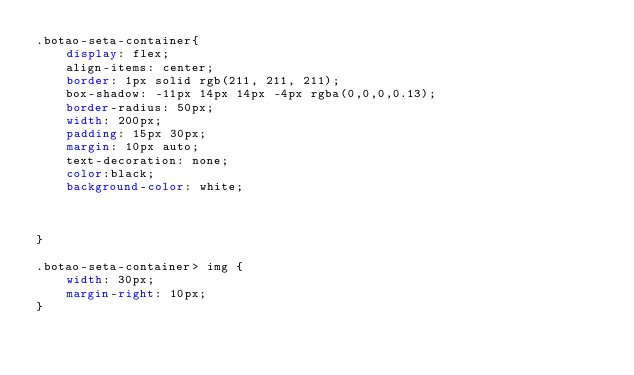Convert code to text. <code><loc_0><loc_0><loc_500><loc_500><_CSS_>.botao-seta-container{
    display: flex;
    align-items: center;
    border: 1px solid rgb(211, 211, 211);
    box-shadow: -11px 14px 14px -4px rgba(0,0,0,0.13);
    border-radius: 50px;
    width: 200px;
    padding: 15px 30px;
    margin: 10px auto;
    text-decoration: none;
    color:black;
    background-color: white;


    
}

.botao-seta-container> img {
    width: 30px;
    margin-right: 10px;
}</code> 